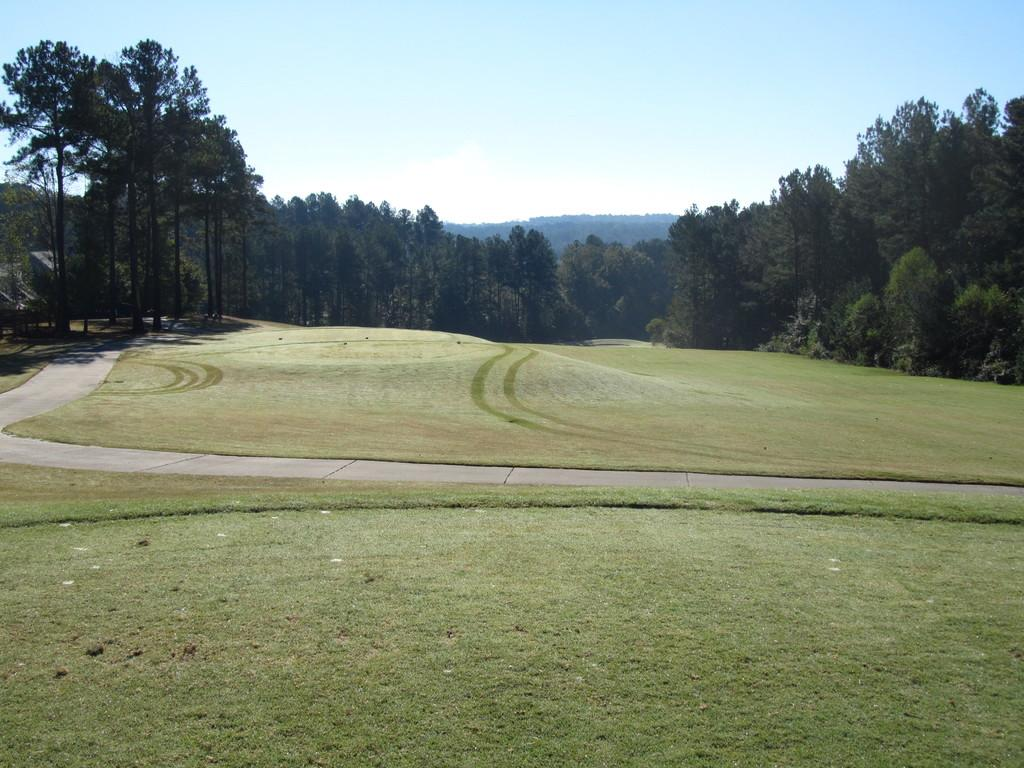What is the main feature of the image? There is a road in the image. What can be seen beside the road? There is grass beside the road. What is visible in the background of the image? There are trees and mountains in the background of the image. What force is acting on the dolls in the image? There are no dolls present in the image, so there is no force acting on them. 